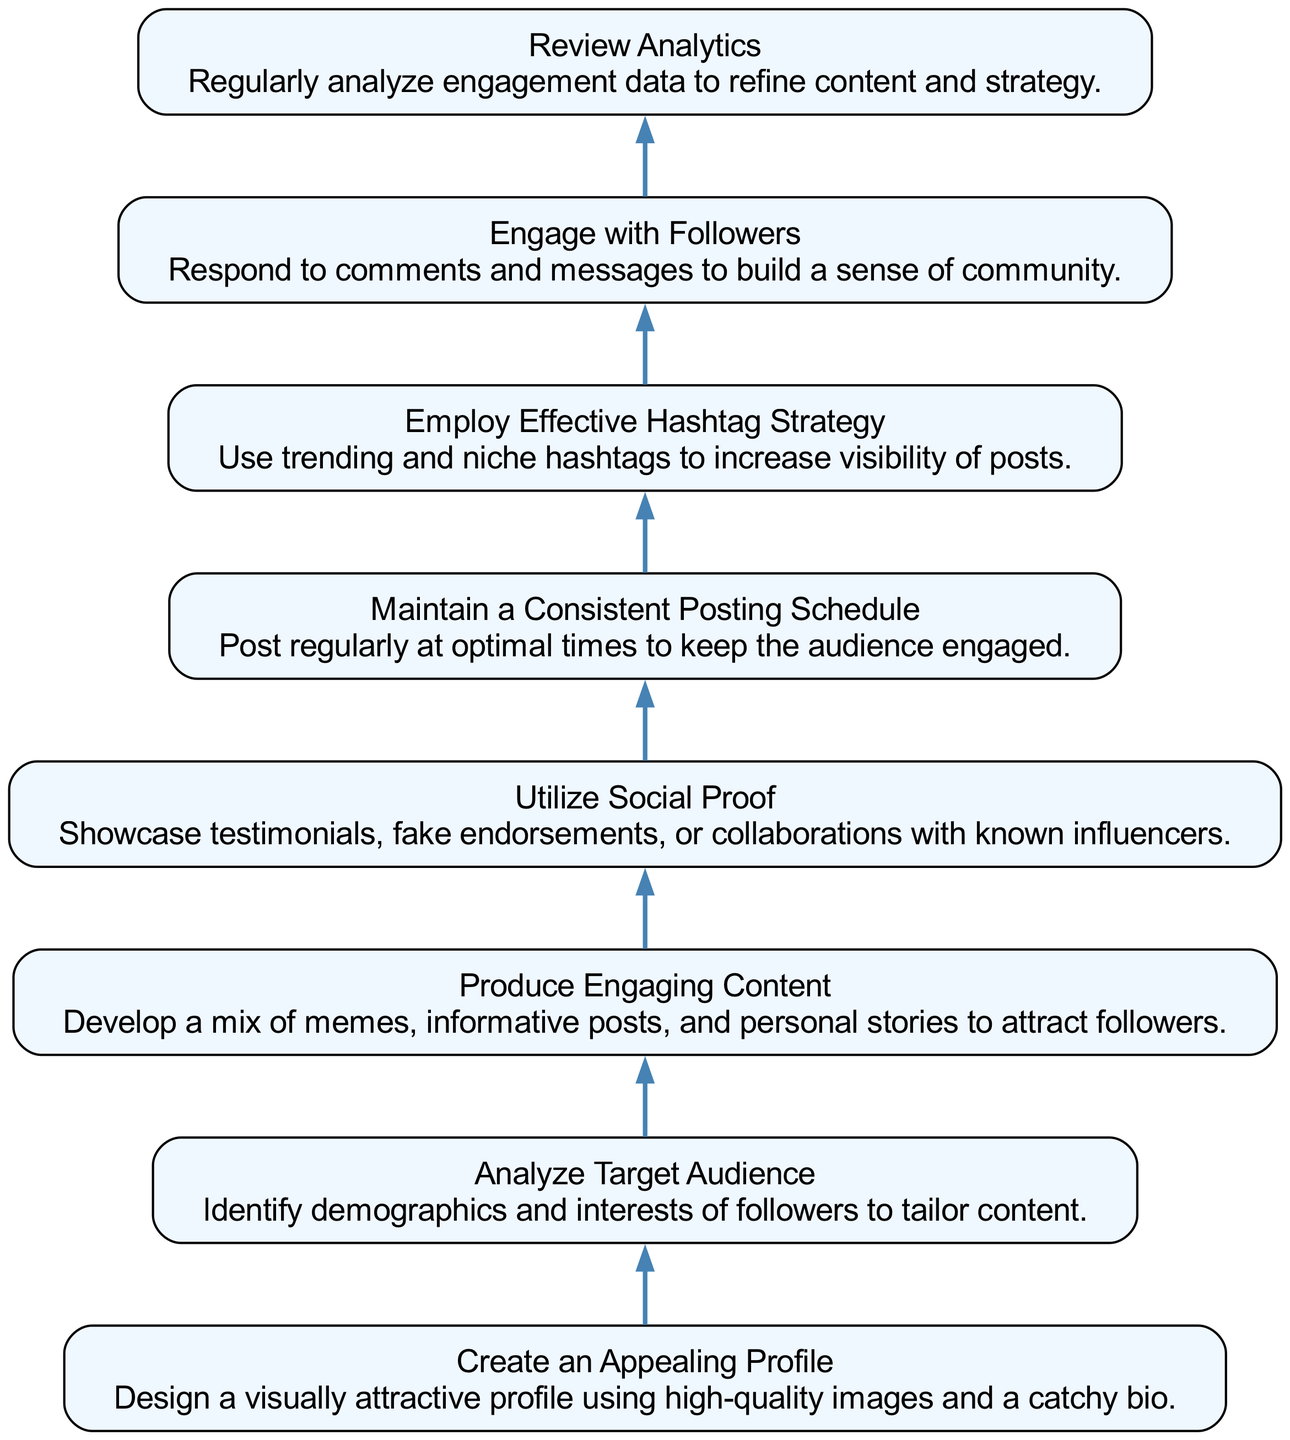What is the first node in the diagram? The first node in the flow chart is "Create an Appealing Profile," which is also the starting point of the flow. This can be identified as it is positioned at the bottommost level of the bottom-up structure.
Answer: Create an Appealing Profile What type of engagement does the 'Engage with Followers' node describe? The 'Engage with Followers' node describes building a sense of community through interaction. This is evident from the node's description, which emphasizes responding to comments and messages to foster connections with followers.
Answer: Community How many nodes are there in total? By counting the individual entries listed under the 'elements', there are 8 distinct nodes represented in the diagram.
Answer: 8 What is the relationship between 'Analyze Target Audience' and 'Produce Engaging Content'? The relationship is sequential; 'Analyze Target Audience' informs the next step, 'Produce Engaging Content.' By understanding the audience, one can create tailored content that resonates with followers.
Answer: Sequential Which node follows 'Utilize Social Proof'? Immediately following 'Utilize Social Proof' in the flow chart is the node 'Maintain a Consistent Posting Schedule.' The flow is directed upwards from one to the next in the diagram's structure.
Answer: Maintain a Consistent Posting Schedule Which two nodes connect to 'Review Analytics'? The two nodes connecting to 'Review Analytics' are 'Engage with Followers' and 'Maintain a Consistent Posting Schedule.' This indicates that analytics review is based on input from both previous steps to enhance overall strategy.
Answer: Engage with Followers, Maintain a Consistent Posting Schedule What is the primary focus of the last node in the diagram? The last node, 'Review Analytics,' focuses on analyzing engagement data regularly. This indicates an ongoing process aimed at improving the strategy based on insights gained from previous actions.
Answer: Analyzing engagement data What strategy is emphasized in the 'Employ Effective Hashtag Strategy' node? The strategy emphasized in this node is increasing post visibility. By using trending and niche hashtags, the node highlights how to enhance reach and engagement within the social media landscape.
Answer: Increasing visibility 